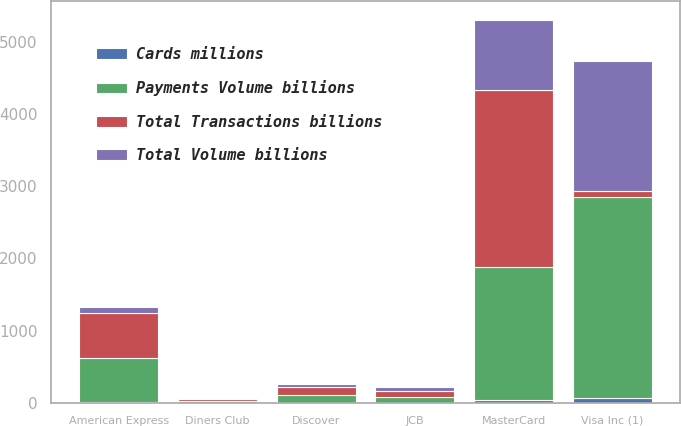Convert chart. <chart><loc_0><loc_0><loc_500><loc_500><stacked_bar_chart><ecel><fcel>Visa Inc (1)<fcel>MasterCard<fcel>American Express<fcel>Discover<fcel>JCB<fcel>Diners Club<nl><fcel>Payments Volume billions<fcel>2793<fcel>1852<fcel>613<fcel>100<fcel>75<fcel>25<nl><fcel>Total Transactions billions<fcel>75<fcel>2454<fcel>620<fcel>109<fcel>83<fcel>26<nl><fcel>Cards millions<fcel>62.2<fcel>32.1<fcel>5.1<fcel>1.7<fcel>0.8<fcel>0.2<nl><fcel>Total Volume billions<fcel>1808<fcel>966<fcel>88<fcel>54<fcel>61<fcel>7<nl></chart> 